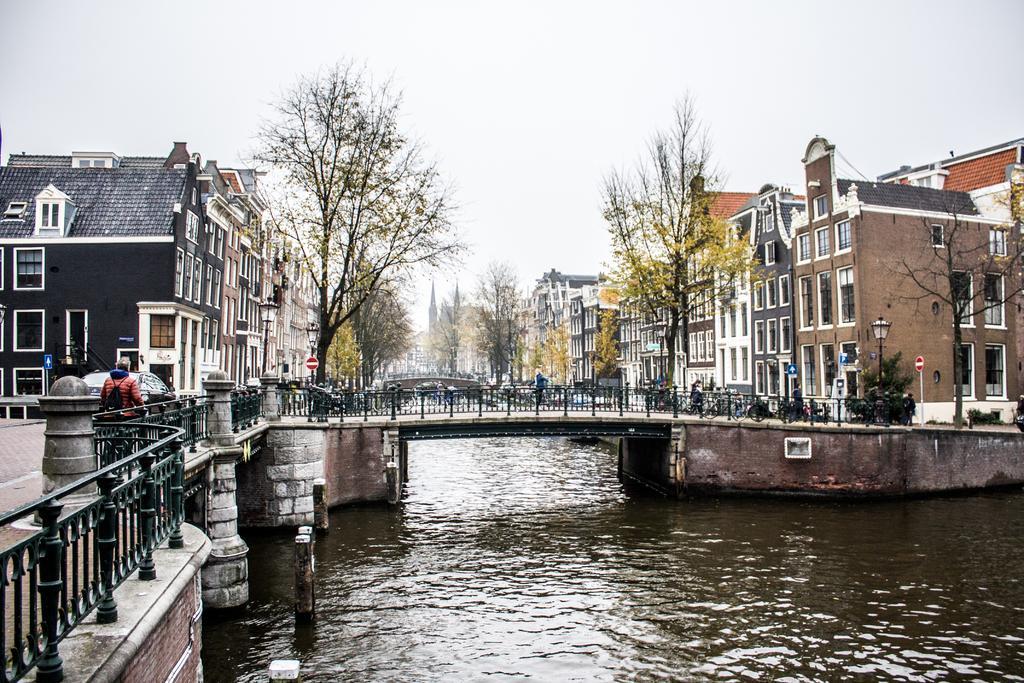Can you describe this image briefly? This picture shows few buildings and we see trees and a bridge and we see a man standing. He wore a backpack on his back and we see water and few sign boards and few people standing and we see another bridge and a cloudy Sky. 